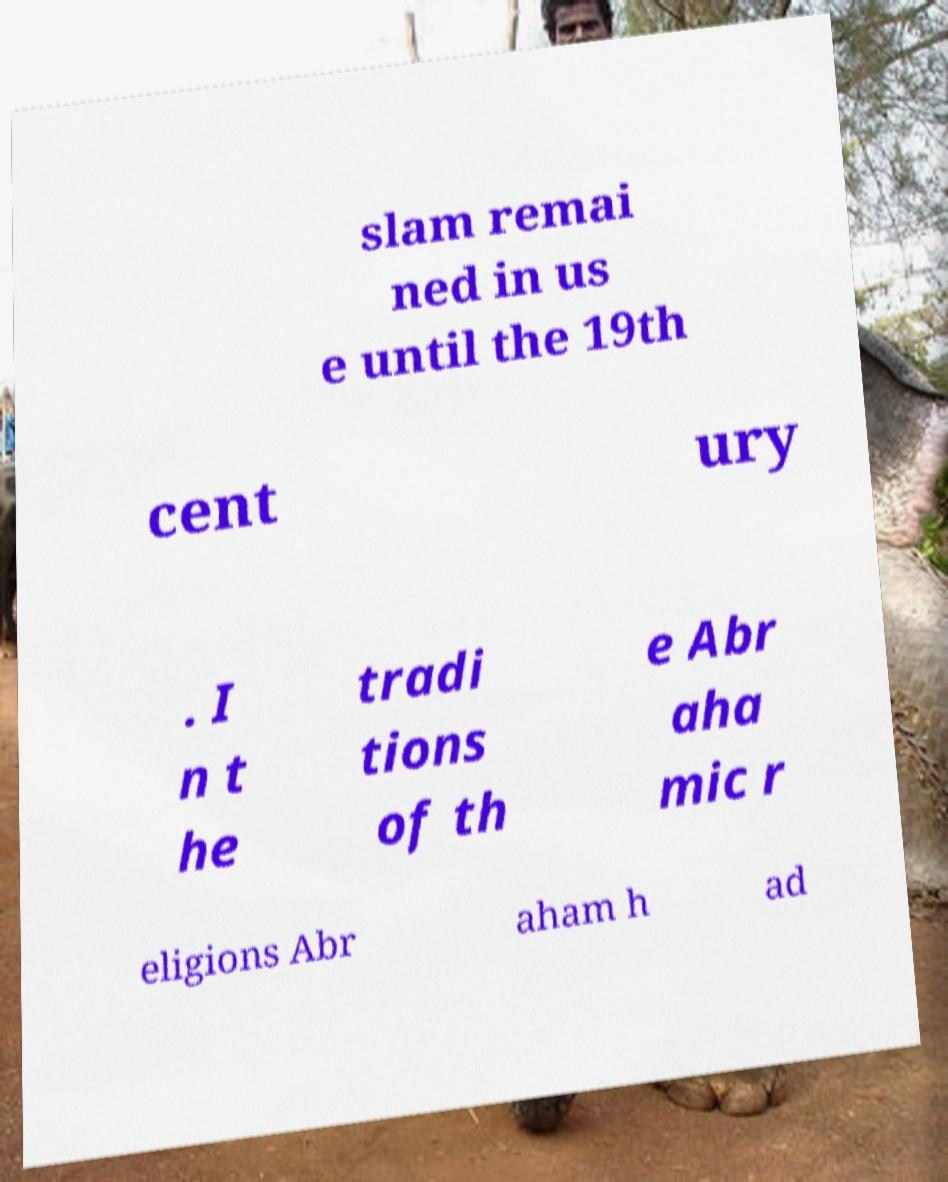Can you read and provide the text displayed in the image?This photo seems to have some interesting text. Can you extract and type it out for me? slam remai ned in us e until the 19th cent ury . I n t he tradi tions of th e Abr aha mic r eligions Abr aham h ad 